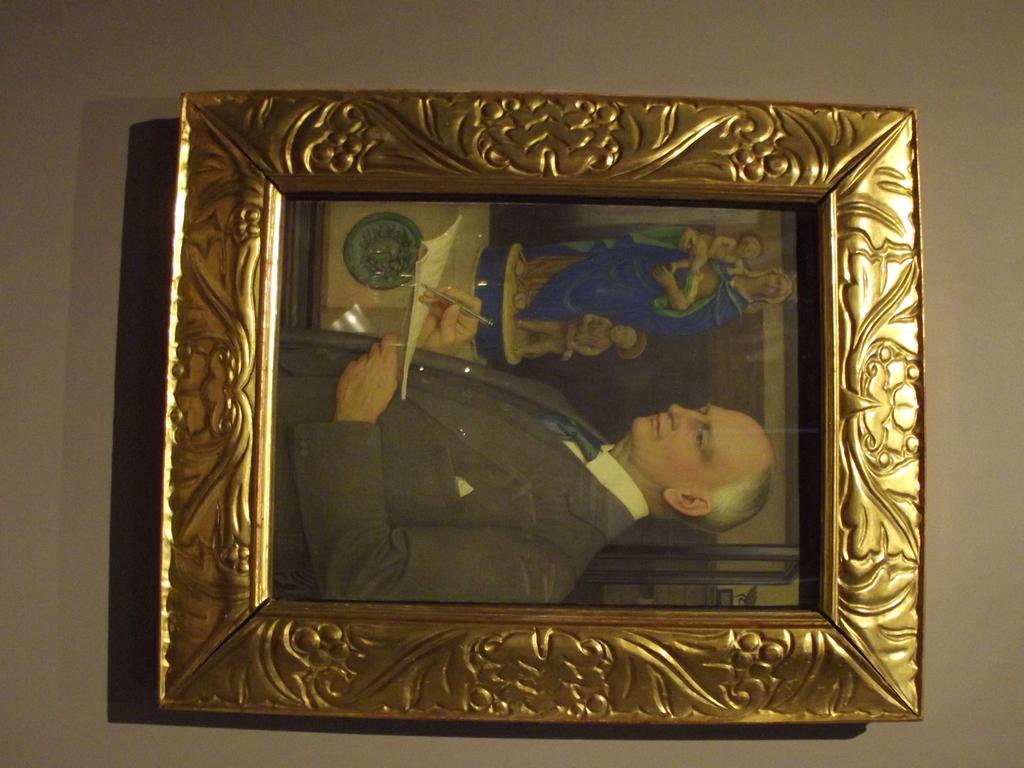What is present in the image that serves as a border or enclosure? There is a frame in the image. Who is the person present in the image? There is a man in the image. What is the man doing in the image? The man is writing in a book. What type of shock can be seen affecting the man in the image? There is no shock present in the image; the man is simply writing in a book. Can you see a truck in the image? No, there is no truck present in the image. Is there a bear visible in the image? No, there is no bear present in the image. 